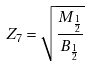Convert formula to latex. <formula><loc_0><loc_0><loc_500><loc_500>Z _ { 7 } = \sqrt { \frac { M _ { \frac { 1 } { 2 } } } { B _ { \frac { 1 } { 2 } } } }</formula> 